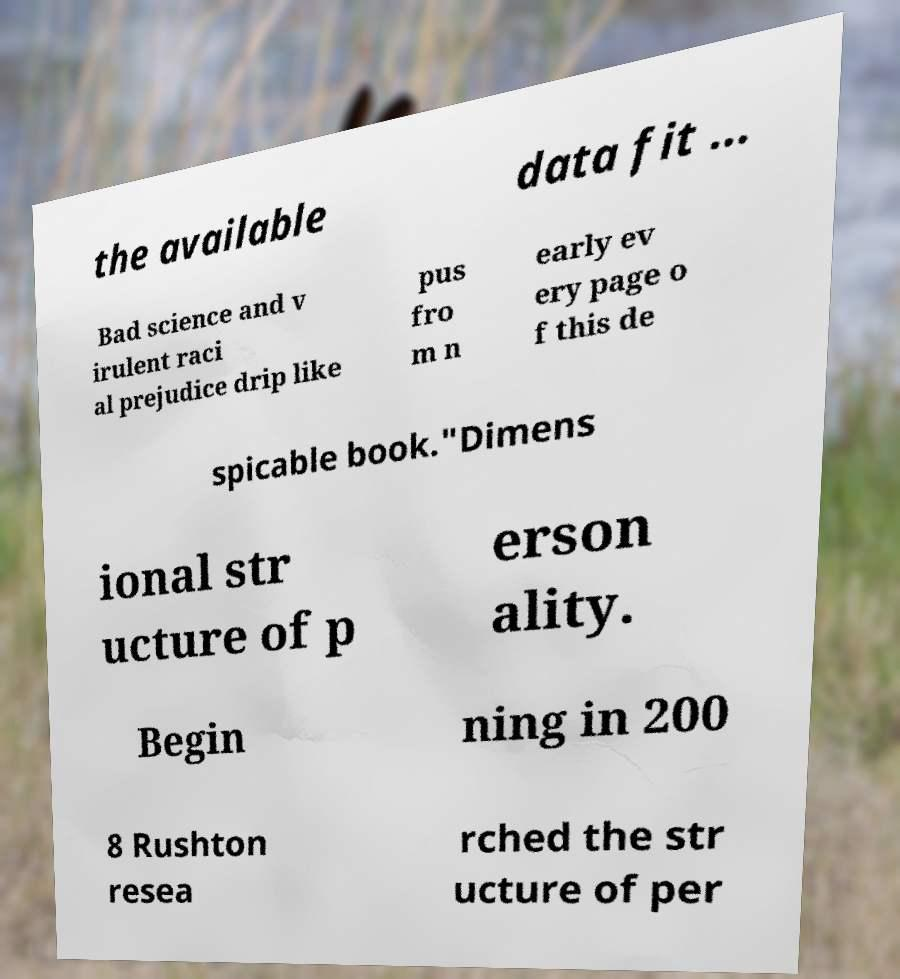Please identify and transcribe the text found in this image. the available data fit ... Bad science and v irulent raci al prejudice drip like pus fro m n early ev ery page o f this de spicable book."Dimens ional str ucture of p erson ality. Begin ning in 200 8 Rushton resea rched the str ucture of per 